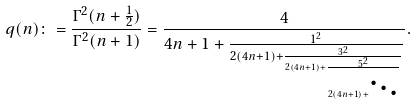Convert formula to latex. <formula><loc_0><loc_0><loc_500><loc_500>q ( n ) \colon = \frac { \Gamma ^ { 2 } ( n + \frac { 1 } { 2 } ) } { \Gamma ^ { 2 } ( n + 1 ) } = \frac { 4 } { 4 n + 1 + \frac { 1 ^ { 2 } } { 2 ( 4 n + 1 ) + \frac { 3 ^ { 2 } } { 2 ( 4 n + 1 ) + \frac { 5 ^ { 2 } } { 2 ( 4 n + 1 ) + \ddots } } } } .</formula> 